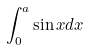<formula> <loc_0><loc_0><loc_500><loc_500>\int _ { 0 } ^ { a } \sin x d x</formula> 